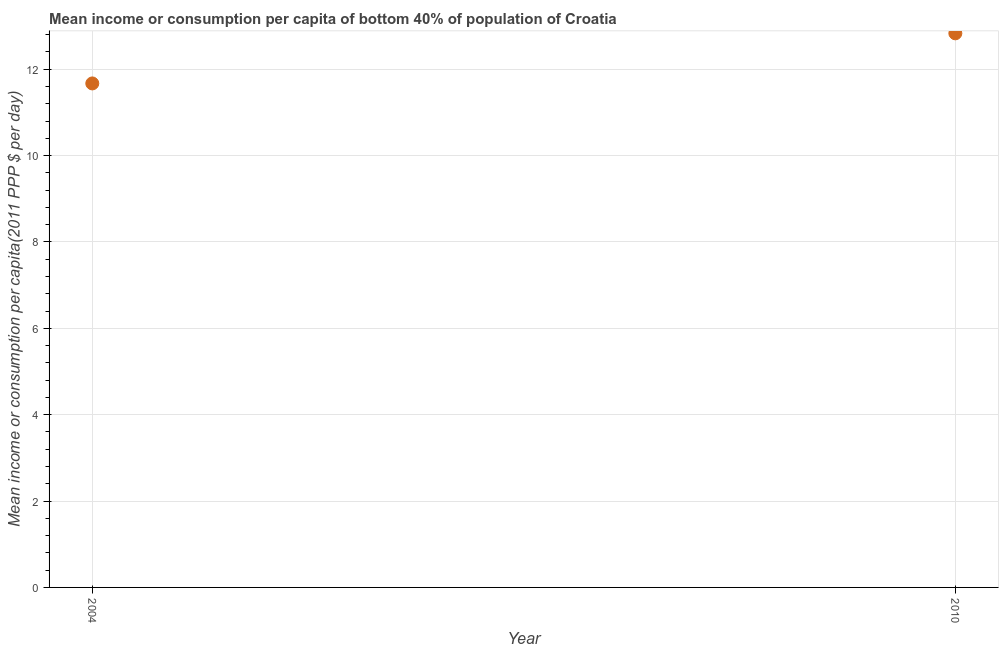What is the mean income or consumption in 2004?
Keep it short and to the point. 11.67. Across all years, what is the maximum mean income or consumption?
Keep it short and to the point. 12.83. Across all years, what is the minimum mean income or consumption?
Ensure brevity in your answer.  11.67. In which year was the mean income or consumption maximum?
Provide a succinct answer. 2010. What is the difference between the mean income or consumption in 2004 and 2010?
Your answer should be compact. -1.16. What is the average mean income or consumption per year?
Make the answer very short. 12.25. What is the median mean income or consumption?
Give a very brief answer. 12.25. What is the ratio of the mean income or consumption in 2004 to that in 2010?
Give a very brief answer. 0.91. Is the mean income or consumption in 2004 less than that in 2010?
Ensure brevity in your answer.  Yes. In how many years, is the mean income or consumption greater than the average mean income or consumption taken over all years?
Provide a succinct answer. 1. Does the mean income or consumption monotonically increase over the years?
Keep it short and to the point. Yes. What is the difference between two consecutive major ticks on the Y-axis?
Offer a terse response. 2. Are the values on the major ticks of Y-axis written in scientific E-notation?
Keep it short and to the point. No. Does the graph contain any zero values?
Ensure brevity in your answer.  No. Does the graph contain grids?
Provide a succinct answer. Yes. What is the title of the graph?
Make the answer very short. Mean income or consumption per capita of bottom 40% of population of Croatia. What is the label or title of the X-axis?
Offer a very short reply. Year. What is the label or title of the Y-axis?
Offer a terse response. Mean income or consumption per capita(2011 PPP $ per day). What is the Mean income or consumption per capita(2011 PPP $ per day) in 2004?
Keep it short and to the point. 11.67. What is the Mean income or consumption per capita(2011 PPP $ per day) in 2010?
Your answer should be compact. 12.83. What is the difference between the Mean income or consumption per capita(2011 PPP $ per day) in 2004 and 2010?
Provide a short and direct response. -1.16. What is the ratio of the Mean income or consumption per capita(2011 PPP $ per day) in 2004 to that in 2010?
Provide a succinct answer. 0.91. 